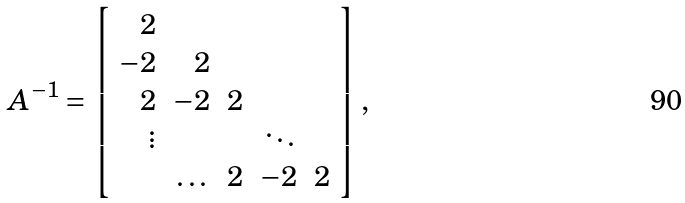<formula> <loc_0><loc_0><loc_500><loc_500>A ^ { - 1 } = \left [ \begin{array} { r r r r r } 2 & & & & \\ - 2 & 2 & & & \\ 2 & - 2 & 2 & & \\ \vdots & & & \ddots \\ & \dots & 2 & - 2 & 2 \\ \end{array} \right ] ,</formula> 